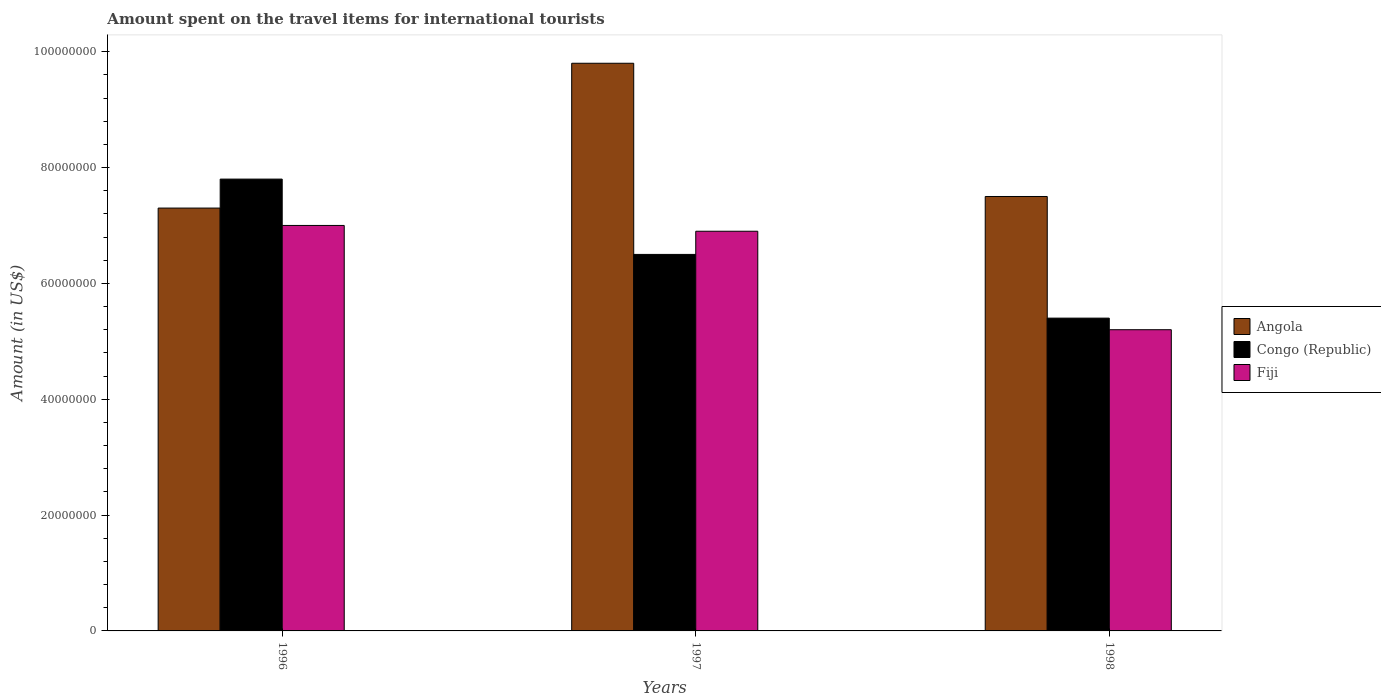How many groups of bars are there?
Your answer should be very brief. 3. How many bars are there on the 2nd tick from the left?
Keep it short and to the point. 3. What is the label of the 2nd group of bars from the left?
Your answer should be very brief. 1997. What is the amount spent on the travel items for international tourists in Fiji in 1998?
Provide a succinct answer. 5.20e+07. Across all years, what is the maximum amount spent on the travel items for international tourists in Fiji?
Offer a very short reply. 7.00e+07. Across all years, what is the minimum amount spent on the travel items for international tourists in Angola?
Your answer should be compact. 7.30e+07. In which year was the amount spent on the travel items for international tourists in Congo (Republic) maximum?
Provide a short and direct response. 1996. In which year was the amount spent on the travel items for international tourists in Angola minimum?
Ensure brevity in your answer.  1996. What is the total amount spent on the travel items for international tourists in Angola in the graph?
Your response must be concise. 2.46e+08. What is the difference between the amount spent on the travel items for international tourists in Angola in 1997 and that in 1998?
Give a very brief answer. 2.30e+07. What is the difference between the amount spent on the travel items for international tourists in Congo (Republic) in 1998 and the amount spent on the travel items for international tourists in Angola in 1997?
Ensure brevity in your answer.  -4.40e+07. What is the average amount spent on the travel items for international tourists in Congo (Republic) per year?
Give a very brief answer. 6.57e+07. In the year 1998, what is the difference between the amount spent on the travel items for international tourists in Angola and amount spent on the travel items for international tourists in Fiji?
Keep it short and to the point. 2.30e+07. What is the ratio of the amount spent on the travel items for international tourists in Angola in 1997 to that in 1998?
Your answer should be compact. 1.31. Is the amount spent on the travel items for international tourists in Angola in 1996 less than that in 1998?
Give a very brief answer. Yes. Is the difference between the amount spent on the travel items for international tourists in Angola in 1997 and 1998 greater than the difference between the amount spent on the travel items for international tourists in Fiji in 1997 and 1998?
Give a very brief answer. Yes. What is the difference between the highest and the second highest amount spent on the travel items for international tourists in Congo (Republic)?
Give a very brief answer. 1.30e+07. What is the difference between the highest and the lowest amount spent on the travel items for international tourists in Fiji?
Provide a short and direct response. 1.80e+07. In how many years, is the amount spent on the travel items for international tourists in Congo (Republic) greater than the average amount spent on the travel items for international tourists in Congo (Republic) taken over all years?
Your response must be concise. 1. What does the 3rd bar from the left in 1997 represents?
Your response must be concise. Fiji. What does the 1st bar from the right in 1996 represents?
Make the answer very short. Fiji. Is it the case that in every year, the sum of the amount spent on the travel items for international tourists in Angola and amount spent on the travel items for international tourists in Congo (Republic) is greater than the amount spent on the travel items for international tourists in Fiji?
Offer a very short reply. Yes. How many years are there in the graph?
Your answer should be compact. 3. Where does the legend appear in the graph?
Make the answer very short. Center right. How many legend labels are there?
Your answer should be very brief. 3. How are the legend labels stacked?
Ensure brevity in your answer.  Vertical. What is the title of the graph?
Keep it short and to the point. Amount spent on the travel items for international tourists. What is the label or title of the X-axis?
Your answer should be very brief. Years. What is the Amount (in US$) of Angola in 1996?
Provide a short and direct response. 7.30e+07. What is the Amount (in US$) in Congo (Republic) in 1996?
Make the answer very short. 7.80e+07. What is the Amount (in US$) of Fiji in 1996?
Your response must be concise. 7.00e+07. What is the Amount (in US$) in Angola in 1997?
Your response must be concise. 9.80e+07. What is the Amount (in US$) of Congo (Republic) in 1997?
Your answer should be very brief. 6.50e+07. What is the Amount (in US$) in Fiji in 1997?
Keep it short and to the point. 6.90e+07. What is the Amount (in US$) of Angola in 1998?
Your response must be concise. 7.50e+07. What is the Amount (in US$) of Congo (Republic) in 1998?
Ensure brevity in your answer.  5.40e+07. What is the Amount (in US$) of Fiji in 1998?
Keep it short and to the point. 5.20e+07. Across all years, what is the maximum Amount (in US$) of Angola?
Offer a terse response. 9.80e+07. Across all years, what is the maximum Amount (in US$) in Congo (Republic)?
Keep it short and to the point. 7.80e+07. Across all years, what is the maximum Amount (in US$) in Fiji?
Your response must be concise. 7.00e+07. Across all years, what is the minimum Amount (in US$) in Angola?
Ensure brevity in your answer.  7.30e+07. Across all years, what is the minimum Amount (in US$) in Congo (Republic)?
Your response must be concise. 5.40e+07. Across all years, what is the minimum Amount (in US$) in Fiji?
Your response must be concise. 5.20e+07. What is the total Amount (in US$) in Angola in the graph?
Provide a short and direct response. 2.46e+08. What is the total Amount (in US$) of Congo (Republic) in the graph?
Your response must be concise. 1.97e+08. What is the total Amount (in US$) in Fiji in the graph?
Provide a short and direct response. 1.91e+08. What is the difference between the Amount (in US$) of Angola in 1996 and that in 1997?
Your response must be concise. -2.50e+07. What is the difference between the Amount (in US$) of Congo (Republic) in 1996 and that in 1997?
Your answer should be very brief. 1.30e+07. What is the difference between the Amount (in US$) of Congo (Republic) in 1996 and that in 1998?
Keep it short and to the point. 2.40e+07. What is the difference between the Amount (in US$) in Fiji in 1996 and that in 1998?
Make the answer very short. 1.80e+07. What is the difference between the Amount (in US$) of Angola in 1997 and that in 1998?
Give a very brief answer. 2.30e+07. What is the difference between the Amount (in US$) of Congo (Republic) in 1997 and that in 1998?
Offer a terse response. 1.10e+07. What is the difference between the Amount (in US$) of Fiji in 1997 and that in 1998?
Make the answer very short. 1.70e+07. What is the difference between the Amount (in US$) in Angola in 1996 and the Amount (in US$) in Congo (Republic) in 1997?
Your answer should be very brief. 8.00e+06. What is the difference between the Amount (in US$) in Congo (Republic) in 1996 and the Amount (in US$) in Fiji in 1997?
Provide a short and direct response. 9.00e+06. What is the difference between the Amount (in US$) of Angola in 1996 and the Amount (in US$) of Congo (Republic) in 1998?
Offer a very short reply. 1.90e+07. What is the difference between the Amount (in US$) in Angola in 1996 and the Amount (in US$) in Fiji in 1998?
Offer a very short reply. 2.10e+07. What is the difference between the Amount (in US$) in Congo (Republic) in 1996 and the Amount (in US$) in Fiji in 1998?
Make the answer very short. 2.60e+07. What is the difference between the Amount (in US$) of Angola in 1997 and the Amount (in US$) of Congo (Republic) in 1998?
Make the answer very short. 4.40e+07. What is the difference between the Amount (in US$) of Angola in 1997 and the Amount (in US$) of Fiji in 1998?
Provide a short and direct response. 4.60e+07. What is the difference between the Amount (in US$) in Congo (Republic) in 1997 and the Amount (in US$) in Fiji in 1998?
Offer a very short reply. 1.30e+07. What is the average Amount (in US$) of Angola per year?
Your response must be concise. 8.20e+07. What is the average Amount (in US$) in Congo (Republic) per year?
Give a very brief answer. 6.57e+07. What is the average Amount (in US$) in Fiji per year?
Ensure brevity in your answer.  6.37e+07. In the year 1996, what is the difference between the Amount (in US$) in Angola and Amount (in US$) in Congo (Republic)?
Offer a very short reply. -5.00e+06. In the year 1996, what is the difference between the Amount (in US$) in Angola and Amount (in US$) in Fiji?
Keep it short and to the point. 3.00e+06. In the year 1997, what is the difference between the Amount (in US$) in Angola and Amount (in US$) in Congo (Republic)?
Offer a terse response. 3.30e+07. In the year 1997, what is the difference between the Amount (in US$) in Angola and Amount (in US$) in Fiji?
Your answer should be very brief. 2.90e+07. In the year 1997, what is the difference between the Amount (in US$) in Congo (Republic) and Amount (in US$) in Fiji?
Keep it short and to the point. -4.00e+06. In the year 1998, what is the difference between the Amount (in US$) in Angola and Amount (in US$) in Congo (Republic)?
Provide a short and direct response. 2.10e+07. In the year 1998, what is the difference between the Amount (in US$) of Angola and Amount (in US$) of Fiji?
Provide a short and direct response. 2.30e+07. In the year 1998, what is the difference between the Amount (in US$) of Congo (Republic) and Amount (in US$) of Fiji?
Your answer should be very brief. 2.00e+06. What is the ratio of the Amount (in US$) in Angola in 1996 to that in 1997?
Provide a short and direct response. 0.74. What is the ratio of the Amount (in US$) of Fiji in 1996 to that in 1997?
Ensure brevity in your answer.  1.01. What is the ratio of the Amount (in US$) of Angola in 1996 to that in 1998?
Make the answer very short. 0.97. What is the ratio of the Amount (in US$) of Congo (Republic) in 1996 to that in 1998?
Make the answer very short. 1.44. What is the ratio of the Amount (in US$) of Fiji in 1996 to that in 1998?
Your response must be concise. 1.35. What is the ratio of the Amount (in US$) in Angola in 1997 to that in 1998?
Provide a short and direct response. 1.31. What is the ratio of the Amount (in US$) in Congo (Republic) in 1997 to that in 1998?
Ensure brevity in your answer.  1.2. What is the ratio of the Amount (in US$) in Fiji in 1997 to that in 1998?
Keep it short and to the point. 1.33. What is the difference between the highest and the second highest Amount (in US$) in Angola?
Make the answer very short. 2.30e+07. What is the difference between the highest and the second highest Amount (in US$) in Congo (Republic)?
Your answer should be very brief. 1.30e+07. What is the difference between the highest and the lowest Amount (in US$) of Angola?
Your answer should be very brief. 2.50e+07. What is the difference between the highest and the lowest Amount (in US$) in Congo (Republic)?
Make the answer very short. 2.40e+07. What is the difference between the highest and the lowest Amount (in US$) of Fiji?
Make the answer very short. 1.80e+07. 